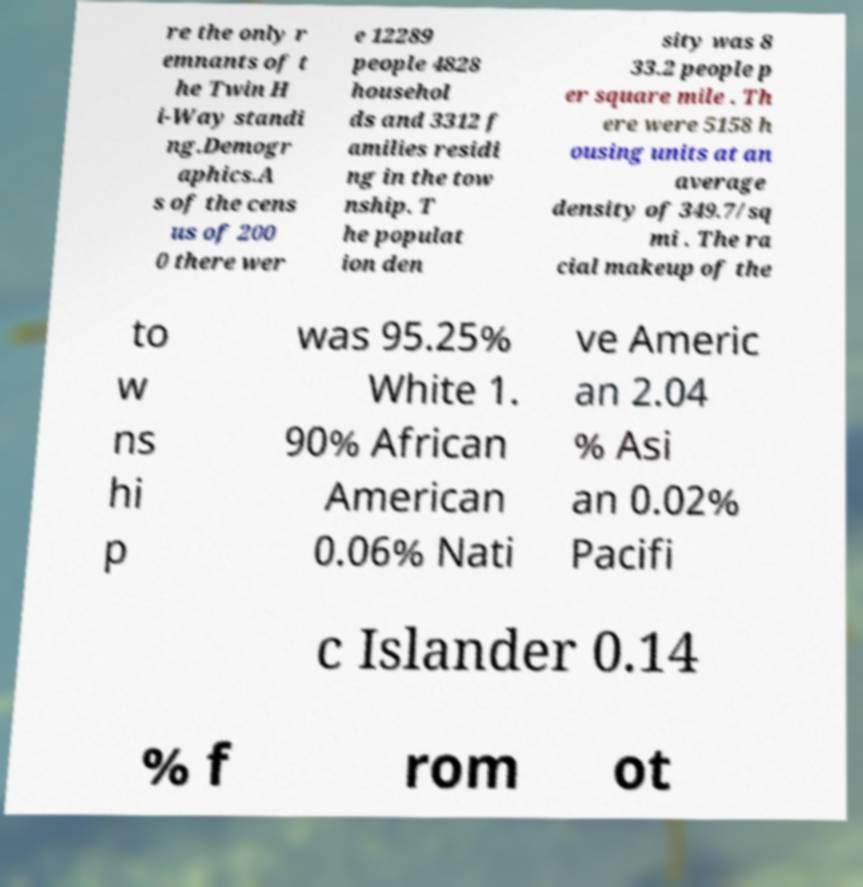For documentation purposes, I need the text within this image transcribed. Could you provide that? re the only r emnants of t he Twin H i-Way standi ng.Demogr aphics.A s of the cens us of 200 0 there wer e 12289 people 4828 househol ds and 3312 f amilies residi ng in the tow nship. T he populat ion den sity was 8 33.2 people p er square mile . Th ere were 5158 h ousing units at an average density of 349.7/sq mi . The ra cial makeup of the to w ns hi p was 95.25% White 1. 90% African American 0.06% Nati ve Americ an 2.04 % Asi an 0.02% Pacifi c Islander 0.14 % f rom ot 